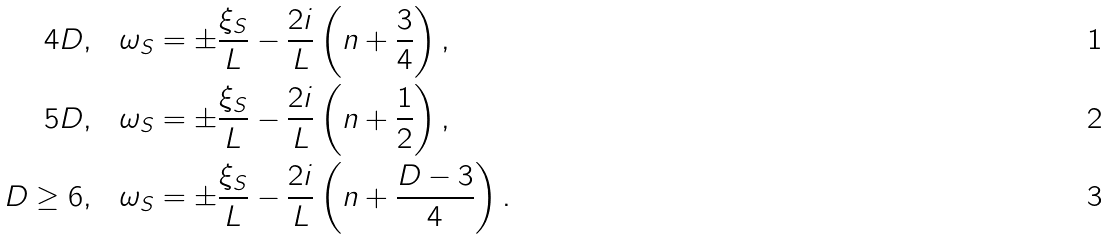<formula> <loc_0><loc_0><loc_500><loc_500>4 D , & \quad \omega _ { S } = \pm \frac { \xi _ { S } } { L } - \frac { 2 i } { L } \left ( n + \frac { 3 } { 4 } \right ) , \\ 5 D , & \quad \omega _ { S } = \pm \frac { \xi _ { S } } { L } - \frac { 2 i } { L } \left ( n + \frac { 1 } { 2 } \right ) , \\ D \geq 6 , & \quad \omega _ { S } = \pm \frac { \xi _ { S } } { L } - \frac { 2 i } { L } \left ( n + \frac { D - 3 } { 4 } \right ) .</formula> 